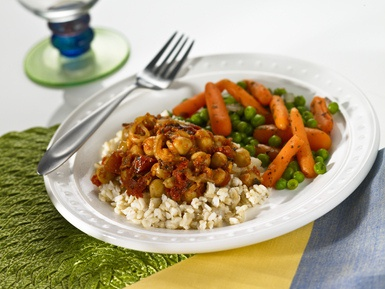Describe the objects in this image and their specific colors. I can see dining table in white, olive, darkgray, brown, and maroon tones, cup in lightgray, ivory, gray, darkgray, and khaki tones, wine glass in lightgray, ivory, gray, darkgray, and khaki tones, fork in lightgray, gray, darkgray, and black tones, and carrot in lightgray, maroon, brown, and red tones in this image. 